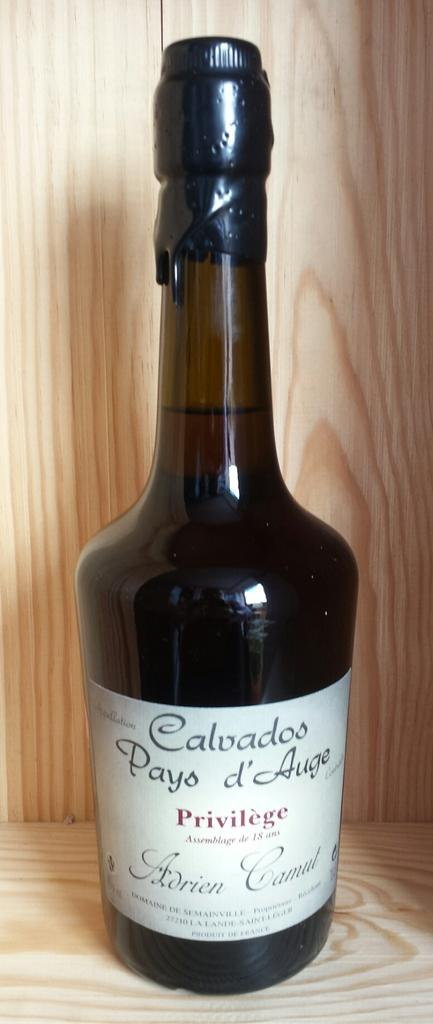What is the main object in the image? There is a wine bottle in the image. Where is the wine bottle placed? The wine bottle is kept on a wooden table. What is the name of the mountain visible in the background of the image? There is no mountain visible in the background of the image. 